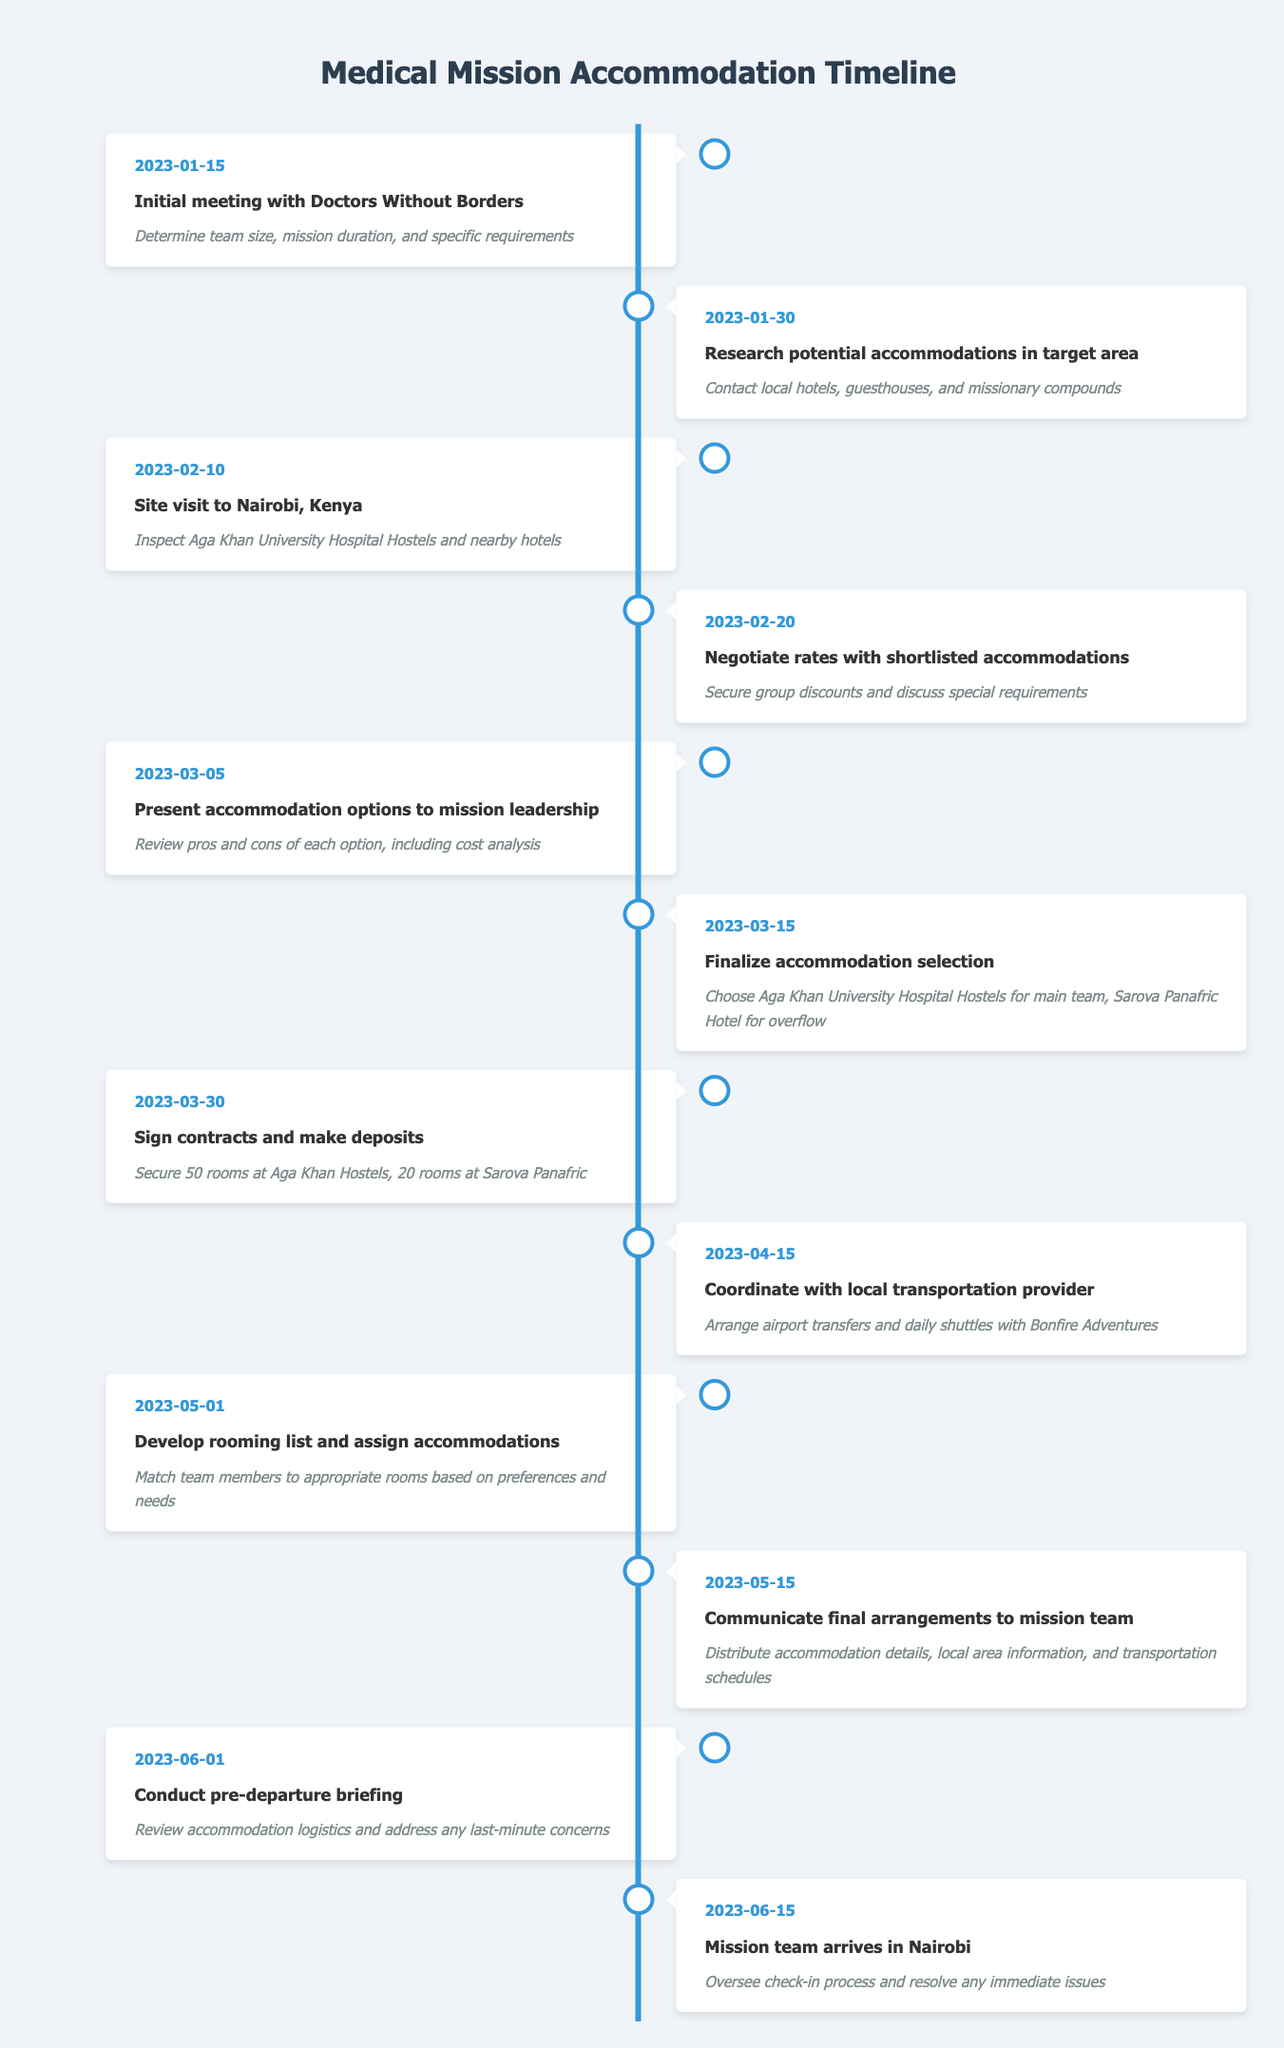What was the date of the initial meeting with Doctors Without Borders? The table indicates that the initial meeting with Doctors Without Borders took place on January 15, 2023. This date is clearly listed in the timeline section of the table.
Answer: January 15, 2023 How many rooms were secured at Aga Khan Hostels? According to the timeline, on March 30, 2023, it mentions that 50 rooms were secured at Aga Khan Hostels. This is a specific detail found in the event related to signing contracts and making deposits.
Answer: 50 rooms Did the mission team conduct a pre-departure briefing? Yes, the table shows that there was a pre-departure briefing conducted on June 1, 2023. This confirms that this step occurred as part of the preparation for the mission.
Answer: Yes What was the difference in the number of rooms secured between Aga Khan Hostels and Sarova Panafric Hotel? The table states that 50 rooms were secured at Aga Khan Hostels and 20 rooms at Sarova Panafric Hotel on March 30, 2023. The difference can be calculated as 50 - 20 = 30. Therefore, 30 more rooms were secured at Aga Khan Hostels compared to Sarova Panafric Hotel.
Answer: 30 How many days were there between the initial meeting and the mission team's arrival in Nairobi? The initial meeting was on January 15, 2023, and the mission team's arrival was on June 15, 2023. First, we calculate the total number of days between these two dates: from January 15 to June 15 is 151 days. Thus, there were a total of 151 days between the two events.
Answer: 151 days Which accommodation was chosen for the main team? The table specifies that the Aga Khan University Hospital Hostels were finalized for the main team on March 15, 2023. This information is explicitly stated in the event's details.
Answer: Aga Khan University Hospital Hostels What was the event that occurred on March 5, 2023? On March 5, 2023, the timeline indicates that accommodation options were presented to mission leadership. This provides insight into the decision-making process regarding the accommodations.
Answer: Present accommodation options to mission leadership What percentage of the total secured rooms were at Sarova Panafric Hotel? The total number of rooms secured is 50 at Aga Khan Hostels and 20 at Sarova Panafric Hotel, making a total of 70 rooms. To find the percentage of rooms at Sarova Panafric Hotel: (20/70) * 100 = 28.57%. Thus, approximately 28.57% of the total secured rooms were at Sarova Panafric Hotel.
Answer: 28.57% 